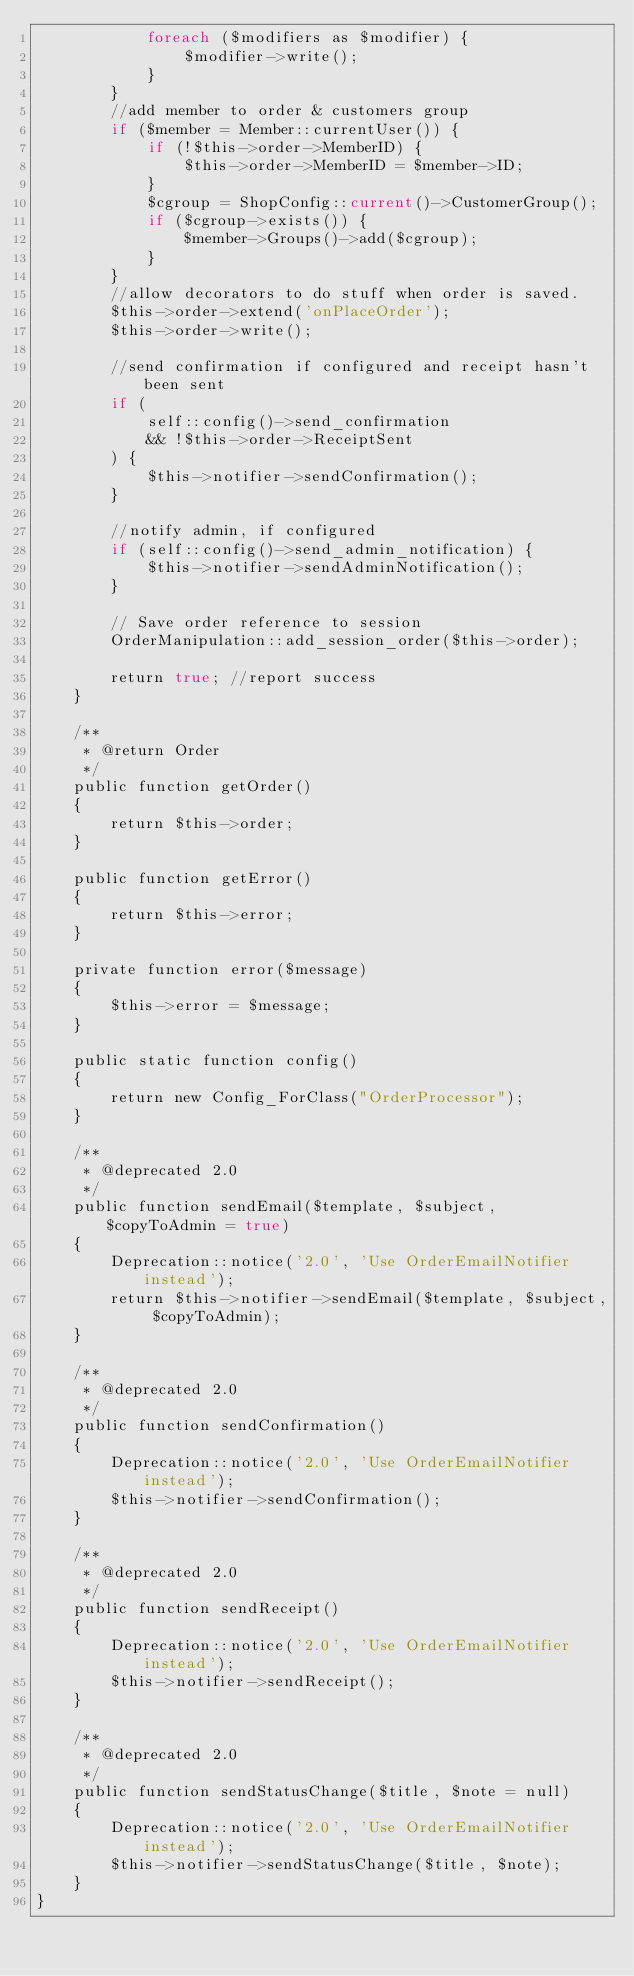<code> <loc_0><loc_0><loc_500><loc_500><_PHP_>            foreach ($modifiers as $modifier) {
                $modifier->write();
            }
        }
        //add member to order & customers group
        if ($member = Member::currentUser()) {
            if (!$this->order->MemberID) {
                $this->order->MemberID = $member->ID;
            }
            $cgroup = ShopConfig::current()->CustomerGroup();
            if ($cgroup->exists()) {
                $member->Groups()->add($cgroup);
            }
        }
        //allow decorators to do stuff when order is saved.
        $this->order->extend('onPlaceOrder');
        $this->order->write();

        //send confirmation if configured and receipt hasn't been sent
        if (
            self::config()->send_confirmation
            && !$this->order->ReceiptSent
        ) {
            $this->notifier->sendConfirmation();
        }

        //notify admin, if configured
        if (self::config()->send_admin_notification) {
            $this->notifier->sendAdminNotification();
        }

        // Save order reference to session
        OrderManipulation::add_session_order($this->order);

        return true; //report success
    }

    /**
     * @return Order
     */
    public function getOrder()
    {
        return $this->order;
    }

    public function getError()
    {
        return $this->error;
    }

    private function error($message)
    {
        $this->error = $message;
    }

    public static function config()
    {
        return new Config_ForClass("OrderProcessor");
    }

    /**
     * @deprecated 2.0
     */
    public function sendEmail($template, $subject, $copyToAdmin = true)
    {
        Deprecation::notice('2.0', 'Use OrderEmailNotifier instead');
        return $this->notifier->sendEmail($template, $subject, $copyToAdmin);
    }

    /**
     * @deprecated 2.0
     */
    public function sendConfirmation()
    {
        Deprecation::notice('2.0', 'Use OrderEmailNotifier instead');
        $this->notifier->sendConfirmation();
    }

    /**
     * @deprecated 2.0
     */
    public function sendReceipt()
    {
        Deprecation::notice('2.0', 'Use OrderEmailNotifier instead');
        $this->notifier->sendReceipt();
    }

    /**
     * @deprecated 2.0
     */
    public function sendStatusChange($title, $note = null)
    {
        Deprecation::notice('2.0', 'Use OrderEmailNotifier instead');
        $this->notifier->sendStatusChange($title, $note);
    }
}
</code> 